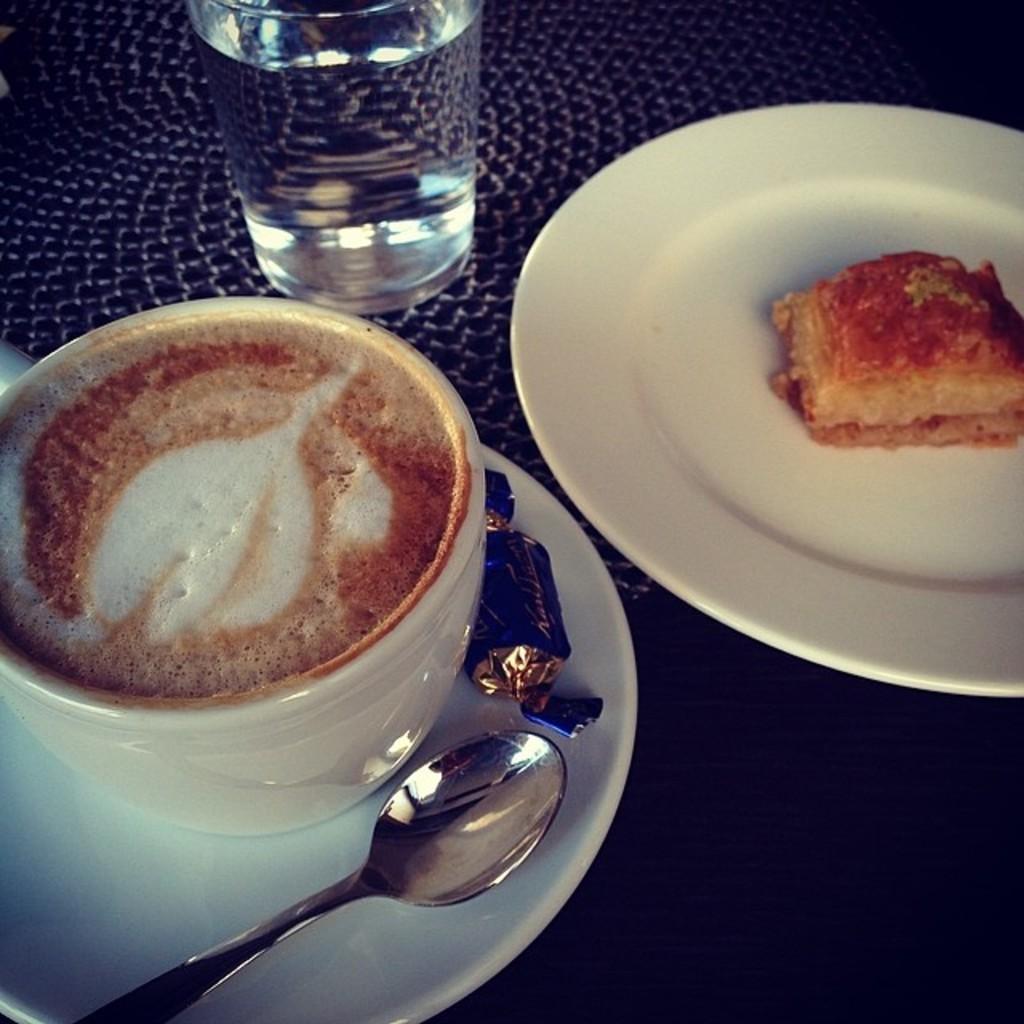In one or two sentences, can you explain what this image depicts? In this image we can see a table. Here we can see a pastry on the plate and it is on the right side. Here we can see a cup and saucer. Here we can see a spoon and a chocolate in the saucer. Here we can see a glass of water on the top left side. 